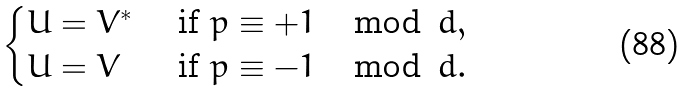<formula> <loc_0><loc_0><loc_500><loc_500>\begin{cases} U = V ^ { * } & \text { if } p \equiv + 1 \, \mod \, d , \\ U = V & \text { if } p \equiv - 1 \, \mod \, d . \end{cases}</formula> 